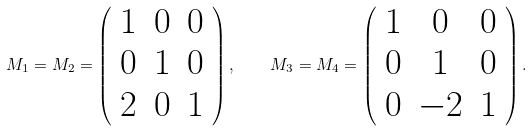Convert formula to latex. <formula><loc_0><loc_0><loc_500><loc_500>M _ { 1 } = M _ { 2 } = \left ( \begin{array} { c c c } 1 & 0 & 0 \\ 0 & 1 & 0 \\ 2 & 0 & 1 \end{array} \right ) , \quad M _ { 3 } = M _ { 4 } = \left ( \begin{array} { c c c } 1 & 0 & 0 \\ 0 & 1 & 0 \\ 0 & - 2 & 1 \end{array} \right ) .</formula> 